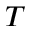<formula> <loc_0><loc_0><loc_500><loc_500>T</formula> 